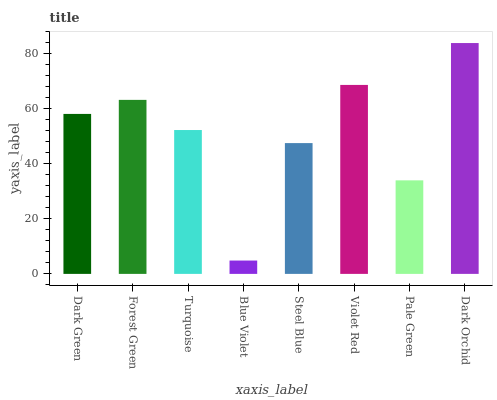Is Blue Violet the minimum?
Answer yes or no. Yes. Is Dark Orchid the maximum?
Answer yes or no. Yes. Is Forest Green the minimum?
Answer yes or no. No. Is Forest Green the maximum?
Answer yes or no. No. Is Forest Green greater than Dark Green?
Answer yes or no. Yes. Is Dark Green less than Forest Green?
Answer yes or no. Yes. Is Dark Green greater than Forest Green?
Answer yes or no. No. Is Forest Green less than Dark Green?
Answer yes or no. No. Is Dark Green the high median?
Answer yes or no. Yes. Is Turquoise the low median?
Answer yes or no. Yes. Is Violet Red the high median?
Answer yes or no. No. Is Steel Blue the low median?
Answer yes or no. No. 